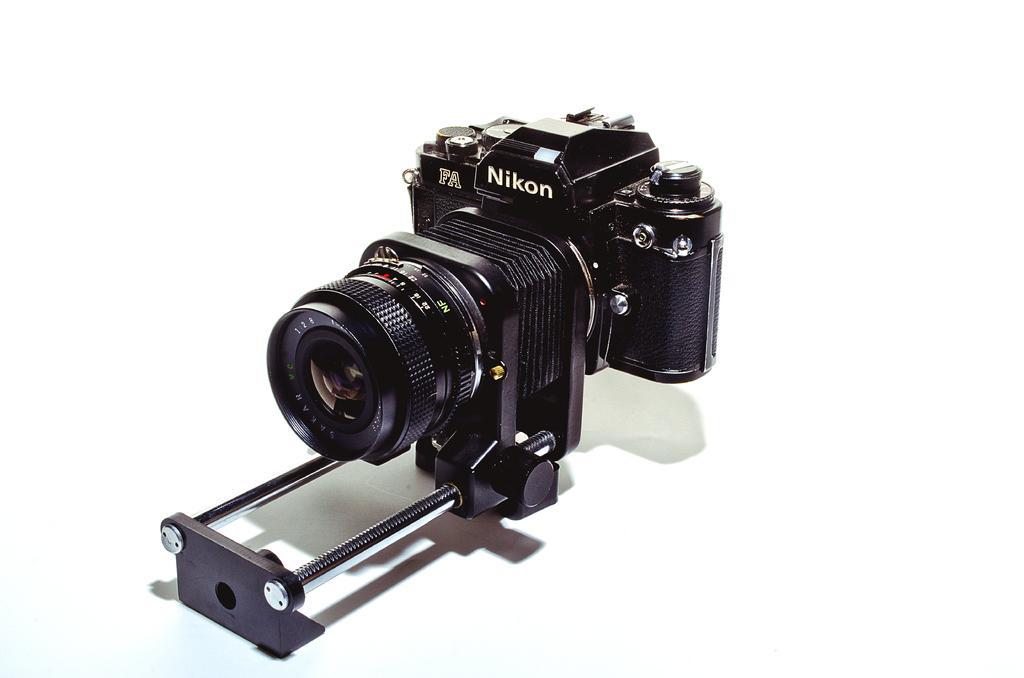In one or two sentences, can you explain what this image depicts? In this picture I can see in the middle there is a camera in black color. 